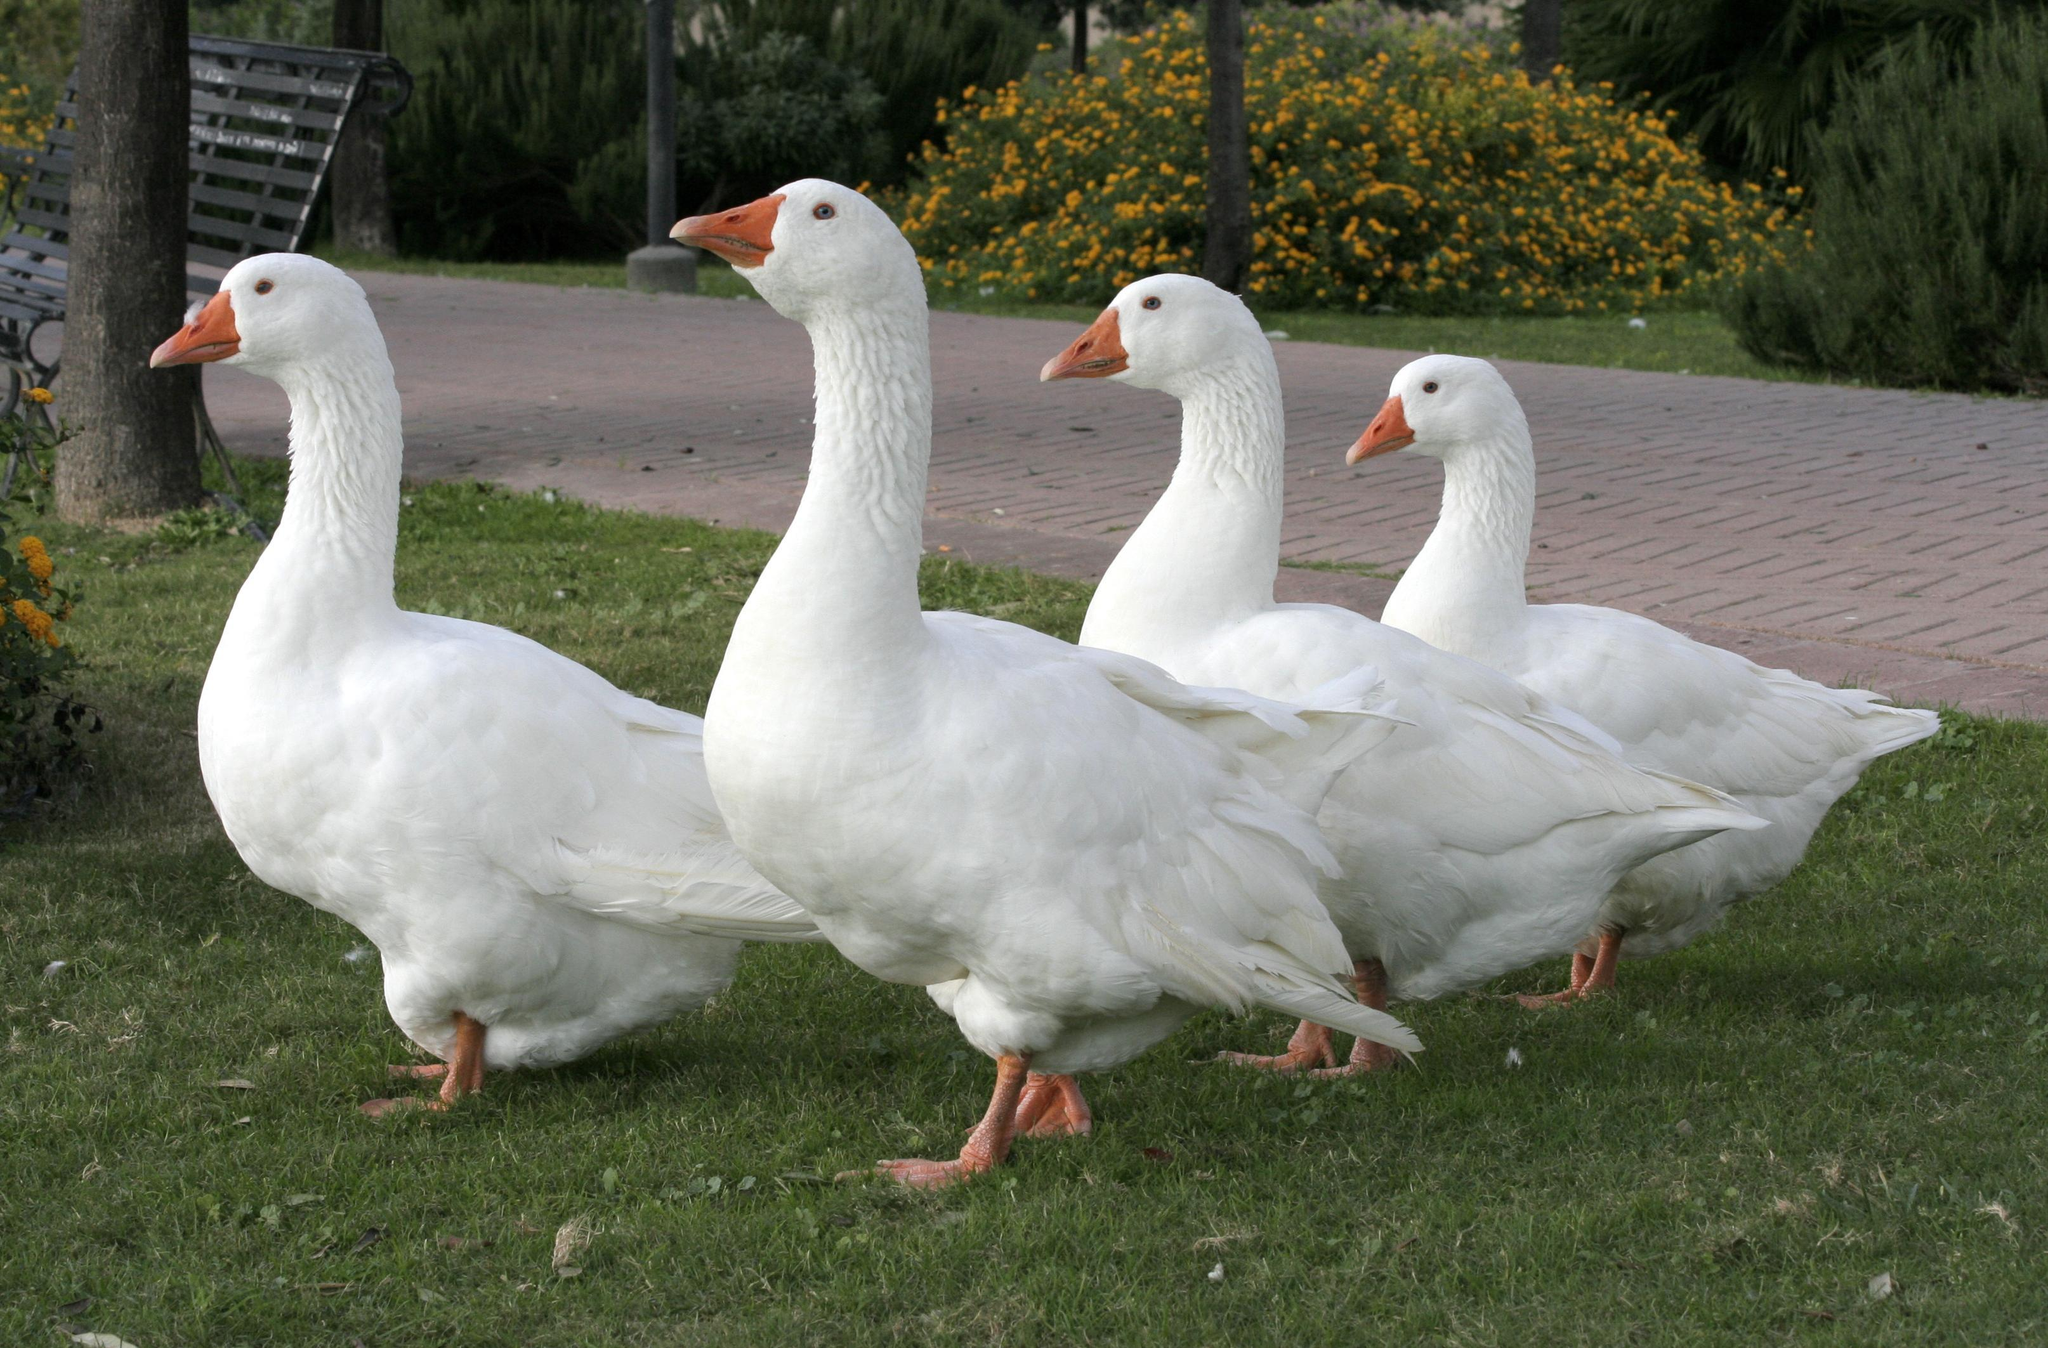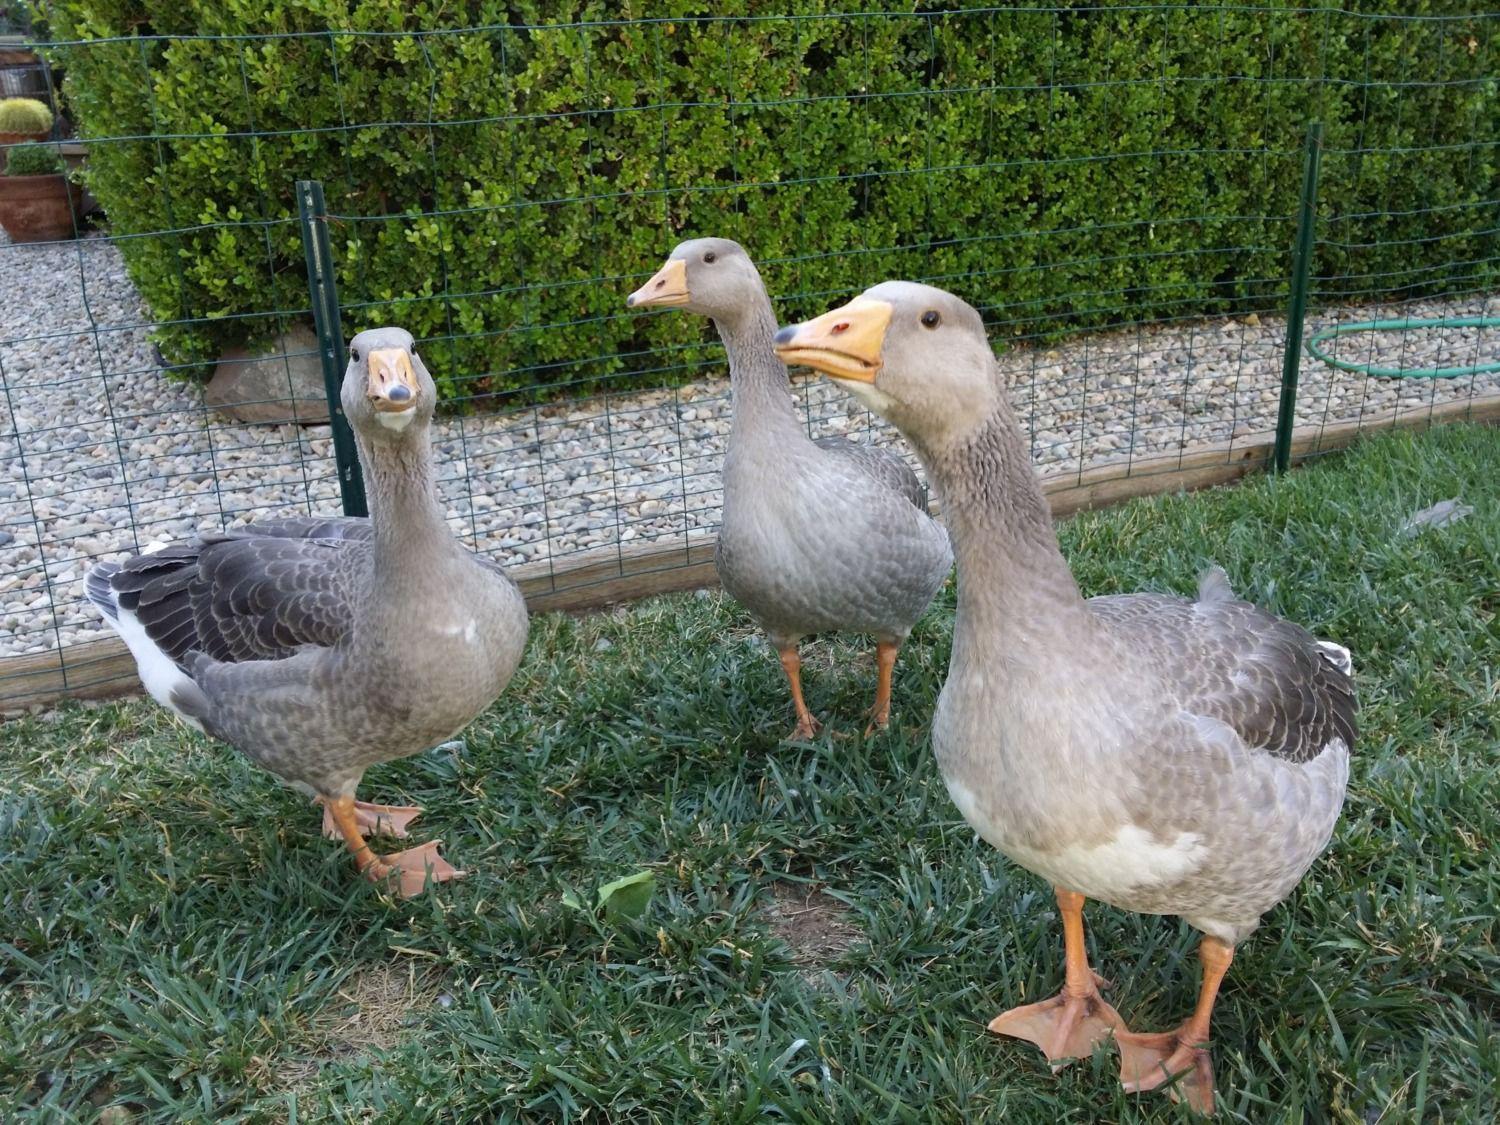The first image is the image on the left, the second image is the image on the right. Examine the images to the left and right. Is the description "One image contains exactly three solid-white ducks, and the other image contains at least one solid-white duck." accurate? Answer yes or no. No. The first image is the image on the left, the second image is the image on the right. For the images displayed, is the sentence "The right image contains exactly two ducks walking on grass." factually correct? Answer yes or no. No. 